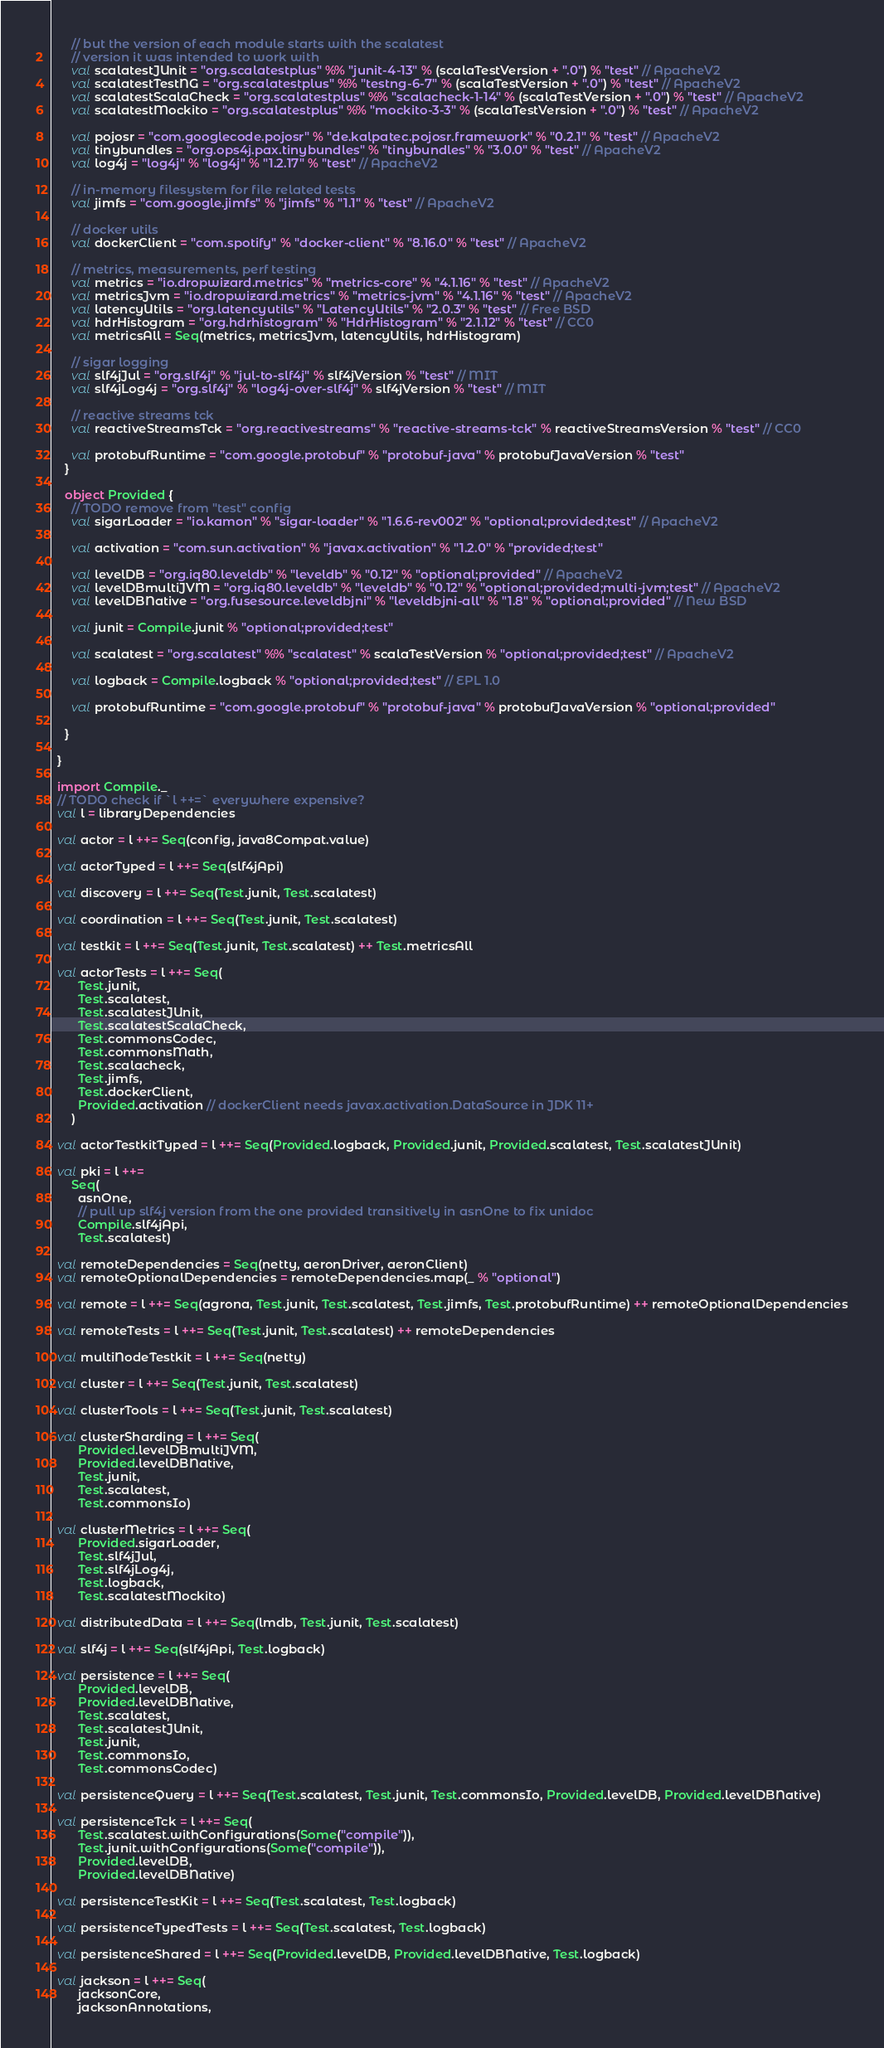Convert code to text. <code><loc_0><loc_0><loc_500><loc_500><_Scala_>      // but the version of each module starts with the scalatest
      // version it was intended to work with
      val scalatestJUnit = "org.scalatestplus" %% "junit-4-13" % (scalaTestVersion + ".0") % "test" // ApacheV2
      val scalatestTestNG = "org.scalatestplus" %% "testng-6-7" % (scalaTestVersion + ".0") % "test" // ApacheV2
      val scalatestScalaCheck = "org.scalatestplus" %% "scalacheck-1-14" % (scalaTestVersion + ".0") % "test" // ApacheV2
      val scalatestMockito = "org.scalatestplus" %% "mockito-3-3" % (scalaTestVersion + ".0") % "test" // ApacheV2

      val pojosr = "com.googlecode.pojosr" % "de.kalpatec.pojosr.framework" % "0.2.1" % "test" // ApacheV2
      val tinybundles = "org.ops4j.pax.tinybundles" % "tinybundles" % "3.0.0" % "test" // ApacheV2
      val log4j = "log4j" % "log4j" % "1.2.17" % "test" // ApacheV2

      // in-memory filesystem for file related tests
      val jimfs = "com.google.jimfs" % "jimfs" % "1.1" % "test" // ApacheV2

      // docker utils
      val dockerClient = "com.spotify" % "docker-client" % "8.16.0" % "test" // ApacheV2

      // metrics, measurements, perf testing
      val metrics = "io.dropwizard.metrics" % "metrics-core" % "4.1.16" % "test" // ApacheV2
      val metricsJvm = "io.dropwizard.metrics" % "metrics-jvm" % "4.1.16" % "test" // ApacheV2
      val latencyUtils = "org.latencyutils" % "LatencyUtils" % "2.0.3" % "test" // Free BSD
      val hdrHistogram = "org.hdrhistogram" % "HdrHistogram" % "2.1.12" % "test" // CC0
      val metricsAll = Seq(metrics, metricsJvm, latencyUtils, hdrHistogram)

      // sigar logging
      val slf4jJul = "org.slf4j" % "jul-to-slf4j" % slf4jVersion % "test" // MIT
      val slf4jLog4j = "org.slf4j" % "log4j-over-slf4j" % slf4jVersion % "test" // MIT

      // reactive streams tck
      val reactiveStreamsTck = "org.reactivestreams" % "reactive-streams-tck" % reactiveStreamsVersion % "test" // CC0

      val protobufRuntime = "com.google.protobuf" % "protobuf-java" % protobufJavaVersion % "test"
    }

    object Provided {
      // TODO remove from "test" config
      val sigarLoader = "io.kamon" % "sigar-loader" % "1.6.6-rev002" % "optional;provided;test" // ApacheV2

      val activation = "com.sun.activation" % "javax.activation" % "1.2.0" % "provided;test"

      val levelDB = "org.iq80.leveldb" % "leveldb" % "0.12" % "optional;provided" // ApacheV2
      val levelDBmultiJVM = "org.iq80.leveldb" % "leveldb" % "0.12" % "optional;provided;multi-jvm;test" // ApacheV2
      val levelDBNative = "org.fusesource.leveldbjni" % "leveldbjni-all" % "1.8" % "optional;provided" // New BSD

      val junit = Compile.junit % "optional;provided;test"

      val scalatest = "org.scalatest" %% "scalatest" % scalaTestVersion % "optional;provided;test" // ApacheV2

      val logback = Compile.logback % "optional;provided;test" // EPL 1.0

      val protobufRuntime = "com.google.protobuf" % "protobuf-java" % protobufJavaVersion % "optional;provided"

    }

  }

  import Compile._
  // TODO check if `l ++=` everywhere expensive?
  val l = libraryDependencies

  val actor = l ++= Seq(config, java8Compat.value)

  val actorTyped = l ++= Seq(slf4jApi)

  val discovery = l ++= Seq(Test.junit, Test.scalatest)

  val coordination = l ++= Seq(Test.junit, Test.scalatest)

  val testkit = l ++= Seq(Test.junit, Test.scalatest) ++ Test.metricsAll

  val actorTests = l ++= Seq(
        Test.junit,
        Test.scalatest,
        Test.scalatestJUnit,
        Test.scalatestScalaCheck,
        Test.commonsCodec,
        Test.commonsMath,
        Test.scalacheck,
        Test.jimfs,
        Test.dockerClient,
        Provided.activation // dockerClient needs javax.activation.DataSource in JDK 11+
      )

  val actorTestkitTyped = l ++= Seq(Provided.logback, Provided.junit, Provided.scalatest, Test.scalatestJUnit)

  val pki = l ++=
      Seq(
        asnOne,
        // pull up slf4j version from the one provided transitively in asnOne to fix unidoc
        Compile.slf4jApi,
        Test.scalatest)

  val remoteDependencies = Seq(netty, aeronDriver, aeronClient)
  val remoteOptionalDependencies = remoteDependencies.map(_ % "optional")

  val remote = l ++= Seq(agrona, Test.junit, Test.scalatest, Test.jimfs, Test.protobufRuntime) ++ remoteOptionalDependencies

  val remoteTests = l ++= Seq(Test.junit, Test.scalatest) ++ remoteDependencies

  val multiNodeTestkit = l ++= Seq(netty)

  val cluster = l ++= Seq(Test.junit, Test.scalatest)

  val clusterTools = l ++= Seq(Test.junit, Test.scalatest)

  val clusterSharding = l ++= Seq(
        Provided.levelDBmultiJVM,
        Provided.levelDBNative,
        Test.junit,
        Test.scalatest,
        Test.commonsIo)

  val clusterMetrics = l ++= Seq(
        Provided.sigarLoader,
        Test.slf4jJul,
        Test.slf4jLog4j,
        Test.logback,
        Test.scalatestMockito)

  val distributedData = l ++= Seq(lmdb, Test.junit, Test.scalatest)

  val slf4j = l ++= Seq(slf4jApi, Test.logback)

  val persistence = l ++= Seq(
        Provided.levelDB,
        Provided.levelDBNative,
        Test.scalatest,
        Test.scalatestJUnit,
        Test.junit,
        Test.commonsIo,
        Test.commonsCodec)

  val persistenceQuery = l ++= Seq(Test.scalatest, Test.junit, Test.commonsIo, Provided.levelDB, Provided.levelDBNative)

  val persistenceTck = l ++= Seq(
        Test.scalatest.withConfigurations(Some("compile")),
        Test.junit.withConfigurations(Some("compile")),
        Provided.levelDB,
        Provided.levelDBNative)

  val persistenceTestKit = l ++= Seq(Test.scalatest, Test.logback)

  val persistenceTypedTests = l ++= Seq(Test.scalatest, Test.logback)

  val persistenceShared = l ++= Seq(Provided.levelDB, Provided.levelDBNative, Test.logback)

  val jackson = l ++= Seq(
        jacksonCore,
        jacksonAnnotations,</code> 